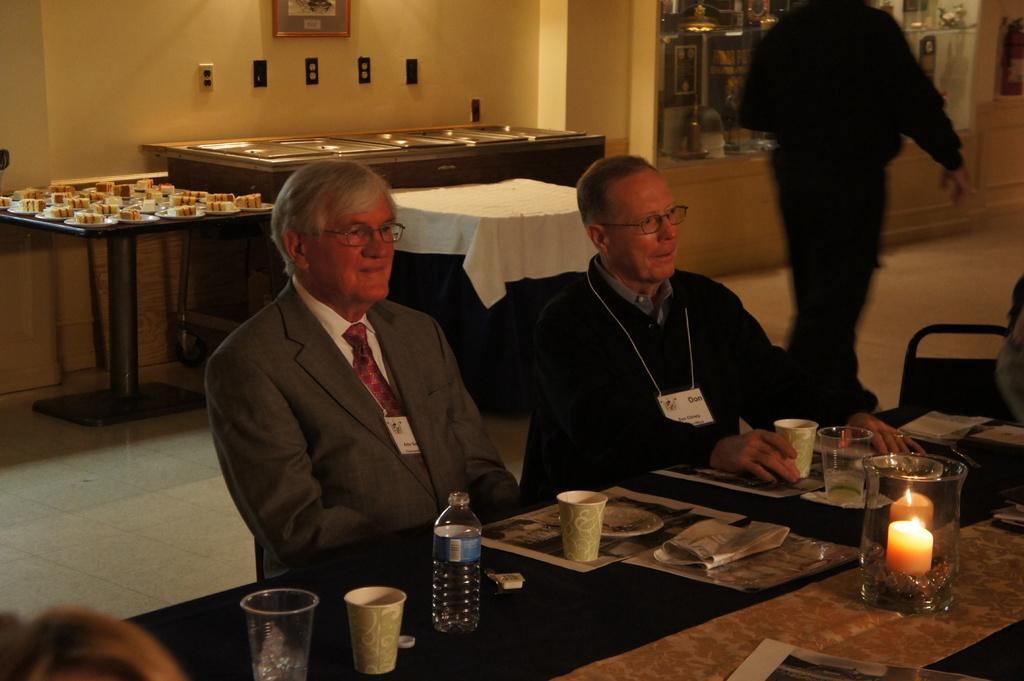Describe this image in one or two sentences. In this image we can see two persons sitting near the table. On the table we can see glasses, water bottle, plates and candle. In the background we can see a table with food items and photo frames on wall. 